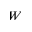Convert formula to latex. <formula><loc_0><loc_0><loc_500><loc_500>W</formula> 